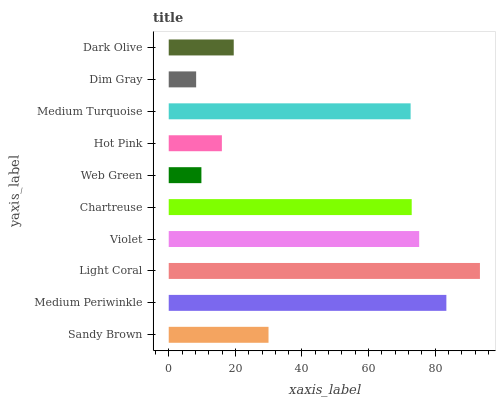Is Dim Gray the minimum?
Answer yes or no. Yes. Is Light Coral the maximum?
Answer yes or no. Yes. Is Medium Periwinkle the minimum?
Answer yes or no. No. Is Medium Periwinkle the maximum?
Answer yes or no. No. Is Medium Periwinkle greater than Sandy Brown?
Answer yes or no. Yes. Is Sandy Brown less than Medium Periwinkle?
Answer yes or no. Yes. Is Sandy Brown greater than Medium Periwinkle?
Answer yes or no. No. Is Medium Periwinkle less than Sandy Brown?
Answer yes or no. No. Is Medium Turquoise the high median?
Answer yes or no. Yes. Is Sandy Brown the low median?
Answer yes or no. Yes. Is Web Green the high median?
Answer yes or no. No. Is Chartreuse the low median?
Answer yes or no. No. 